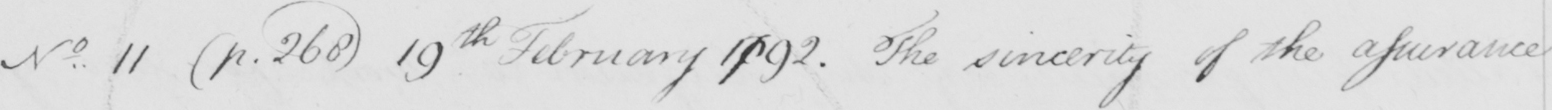Please provide the text content of this handwritten line. N . 11  ( p . 268 )  19th February 1792 . The sincerity of the assurance 